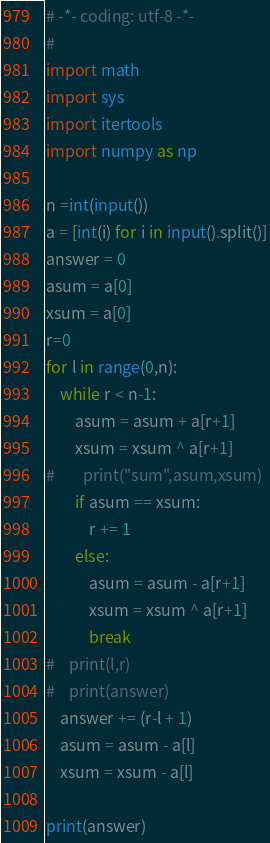Convert code to text. <code><loc_0><loc_0><loc_500><loc_500><_Python_># -*- coding: utf-8 -*-
# 
import math
import sys
import itertools
import numpy as np

n =int(input())
a = [int(i) for i in input().split()]
answer = 0
asum = a[0]
xsum = a[0]
r=0
for l in range(0,n):
    while r < n-1:
        asum = asum + a[r+1]
        xsum = xsum ^ a[r+1]
#        print("sum",asum,xsum)
        if asum == xsum:
            r += 1
        else:
            asum = asum - a[r+1]
            xsum = xsum ^ a[r+1]
            break
#    print(l,r)
#    print(answer)
    answer += (r-l + 1)
    asum = asum - a[l]
    xsum = xsum - a[l]

print(answer)
</code> 